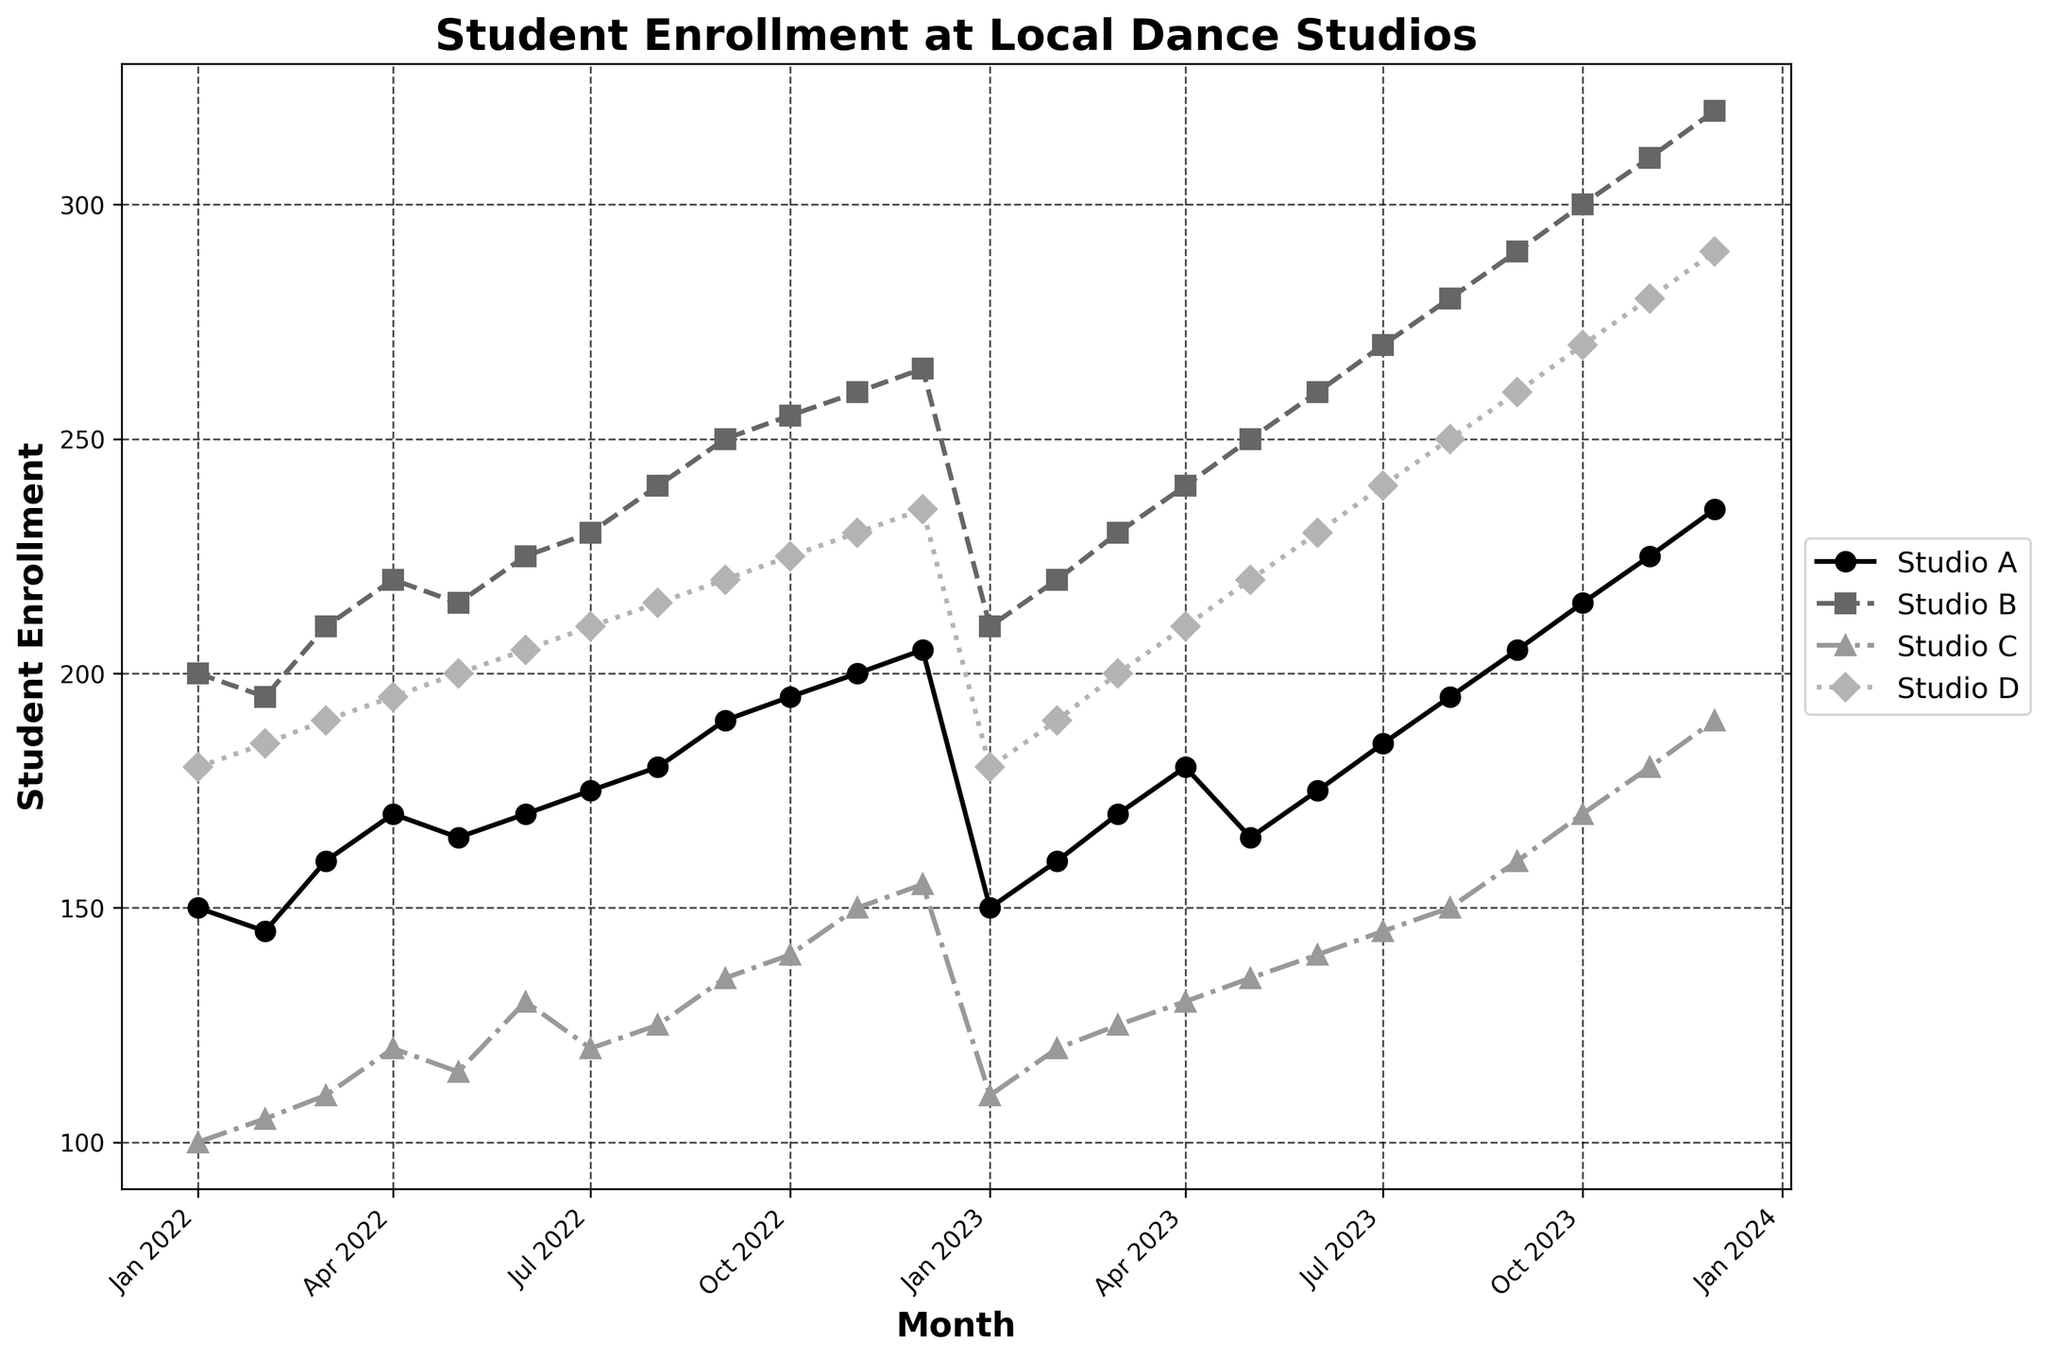What's the title of the plot? The title is usually displayed at the top of the figure. In this case, it clearly states, "Student Enrollment at Local Dance Studios".
Answer: Student Enrollment at Local Dance Studios How many studios are represented in the plot? The legend displays the names of all studios. By counting the entries, we can determine how many studios are represented.
Answer: 4 Which month shows the highest enrollment for Studio_B? By looking at the line representing Studio_B (marked with squares and a dashed line), the highest point can be identified. It is shown at October 2023.
Answer: October 2023 Which studio had the highest enrollment in December 2023? By looking at the plot, we can see that Studio_B has the highest point in December 2023.
Answer: Studio_B What's the general trend of Studio_D from January 2022 to December 2023? Observing the line representing Studio_D across all months, it shows a general upward trajectory from around 180 students to approximately 290 students.
Answer: Increasing What is the difference in student enrollment between Studio_A and Studio_C in July 2023? Find the data points for both Studio_A and Studio_C in July 2023. Then, subtract Studio_C's enrollment (145) from Studio_A's enrollment (185).
Answer: 40 Which studio experienced the greatest increase in student enrollment from January 2022 to December 2023? By comparison of initial (January 2022) and final (December 2023) data points for each studio, Studio_D shows an increase from 180 to 290, the highest among all studios.
Answer: Studio_D During which month did Studio_A have an enrollment of 160 students for the first time? The plot shows that the first time Studio_A’s line reaches 160 students is in March 2022.
Answer: March 2022 